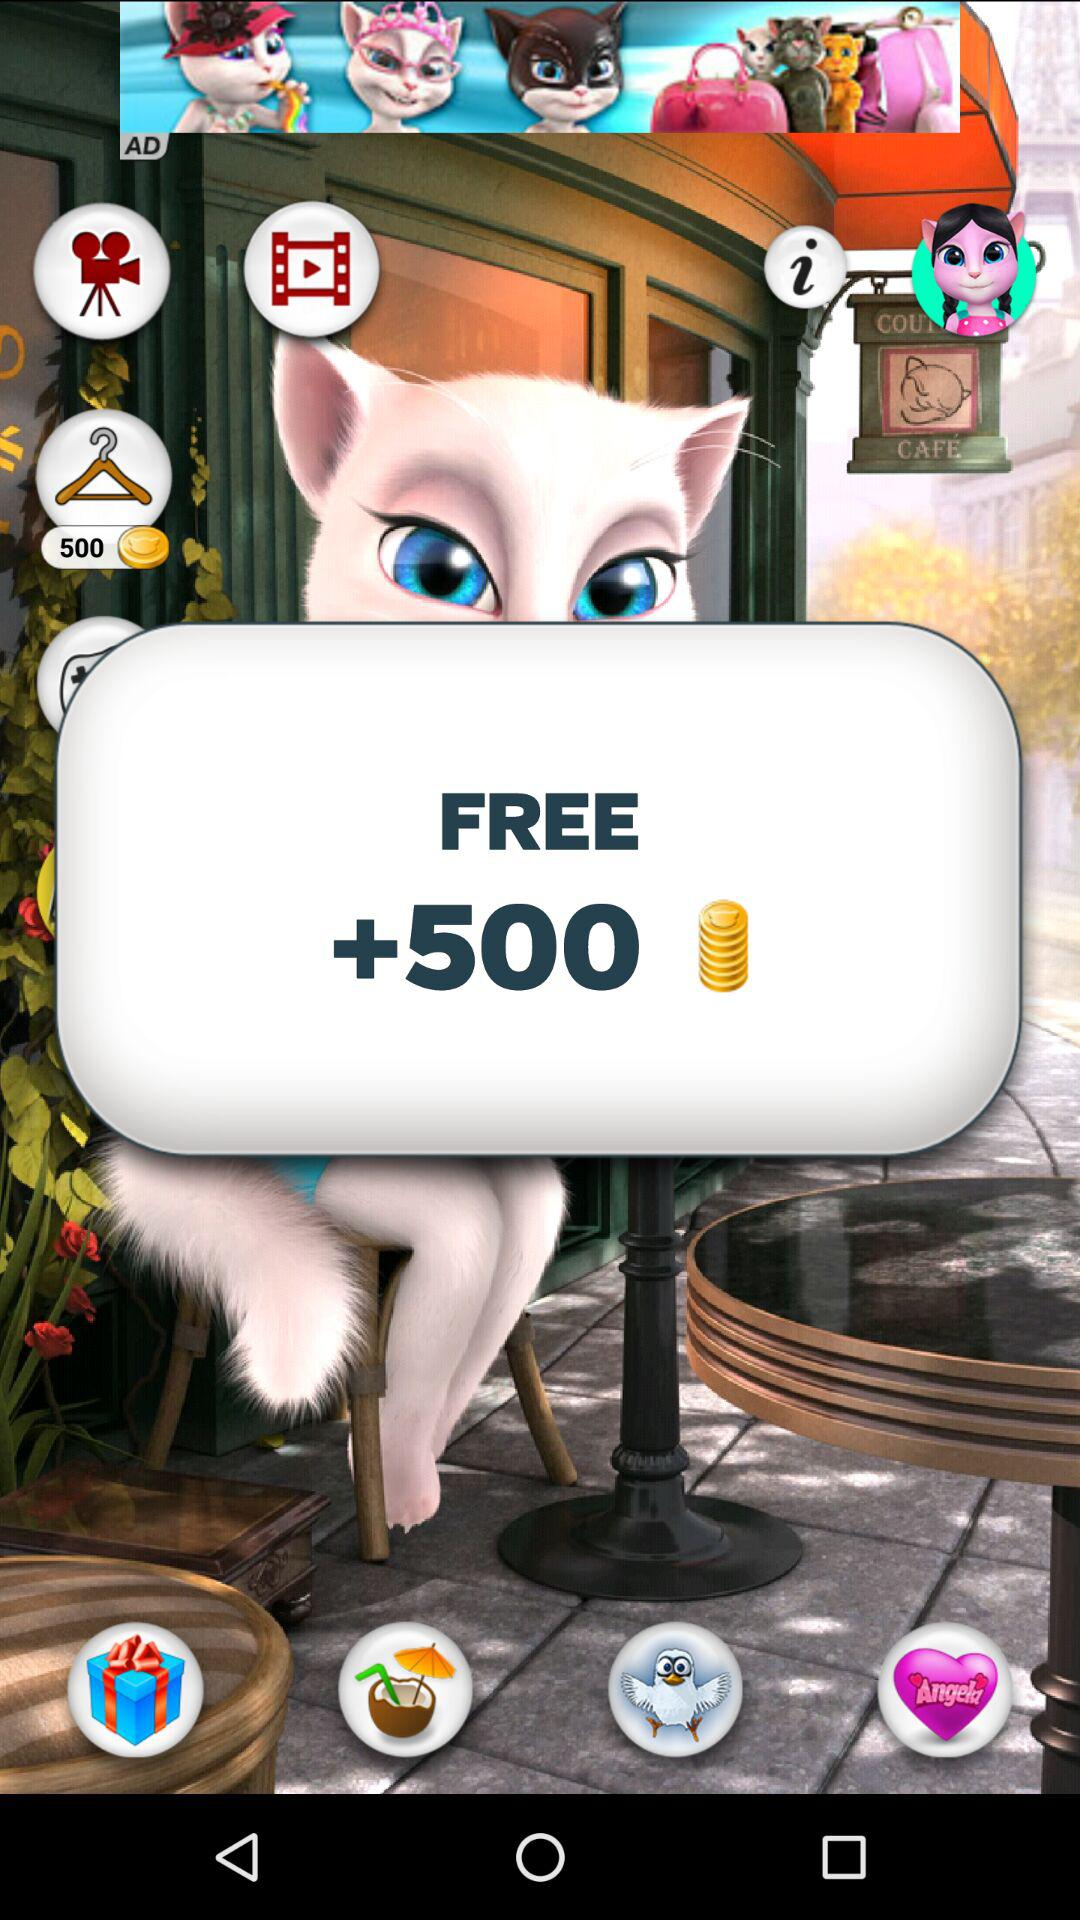Which movies are available?
When the provided information is insufficient, respond with <no answer>. <no answer> 